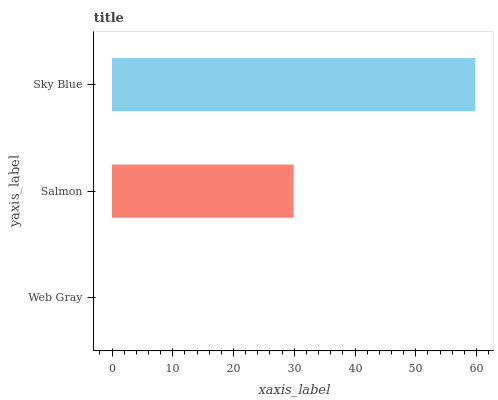Is Web Gray the minimum?
Answer yes or no. Yes. Is Sky Blue the maximum?
Answer yes or no. Yes. Is Salmon the minimum?
Answer yes or no. No. Is Salmon the maximum?
Answer yes or no. No. Is Salmon greater than Web Gray?
Answer yes or no. Yes. Is Web Gray less than Salmon?
Answer yes or no. Yes. Is Web Gray greater than Salmon?
Answer yes or no. No. Is Salmon less than Web Gray?
Answer yes or no. No. Is Salmon the high median?
Answer yes or no. Yes. Is Salmon the low median?
Answer yes or no. Yes. Is Sky Blue the high median?
Answer yes or no. No. Is Sky Blue the low median?
Answer yes or no. No. 